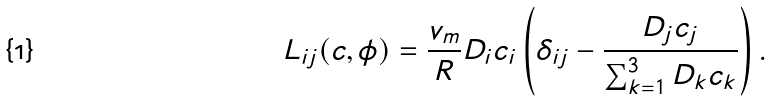<formula> <loc_0><loc_0><loc_500><loc_500>L _ { i j } ( c , \phi ) = \frac { v _ { m } } { R } D _ { i } c _ { i } \left ( \delta _ { i j } - \frac { D _ { j } c _ { j } } { \sum _ { k = 1 } ^ { 3 } D _ { k } c _ { k } } \right ) .</formula> 